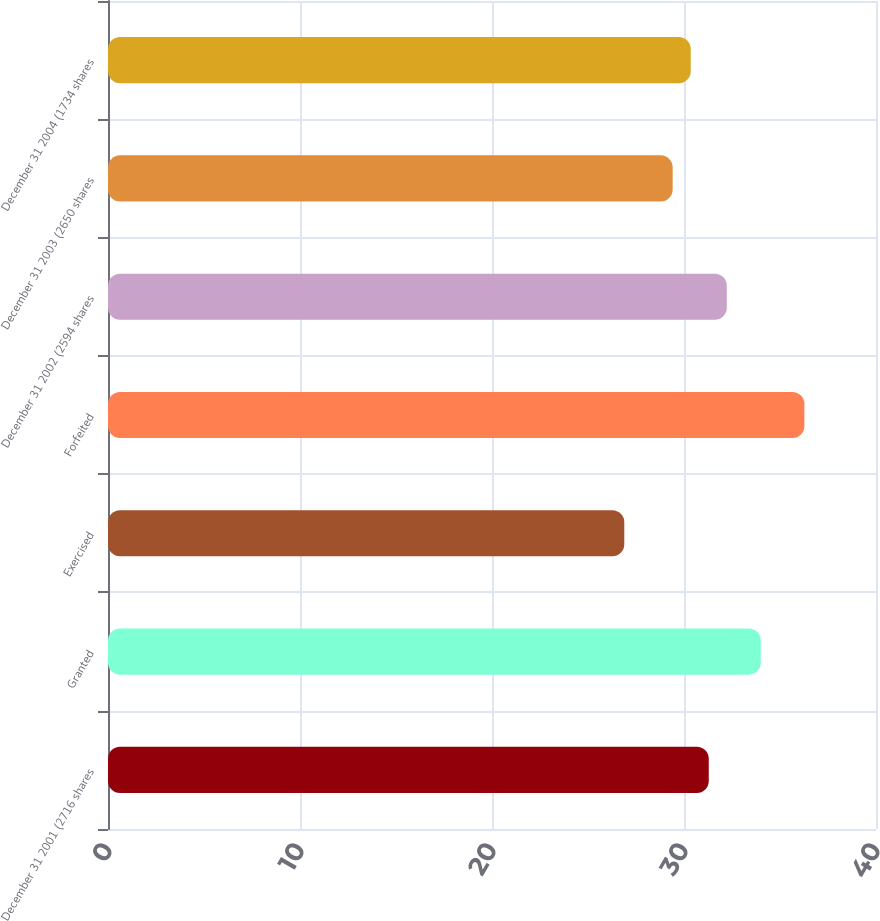Convert chart to OTSL. <chart><loc_0><loc_0><loc_500><loc_500><bar_chart><fcel>December 31 2001 (2716 shares<fcel>Granted<fcel>Exercised<fcel>Forfeited<fcel>December 31 2002 (2594 shares<fcel>December 31 2003 (2650 shares<fcel>December 31 2004 (1734 shares<nl><fcel>31.29<fcel>34<fcel>26.89<fcel>36.27<fcel>32.23<fcel>29.41<fcel>30.35<nl></chart> 